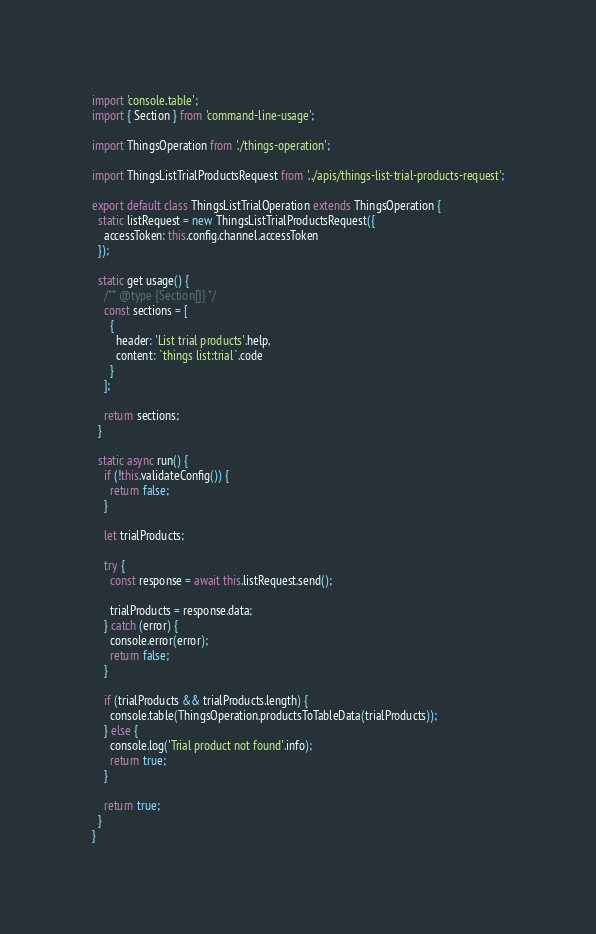Convert code to text. <code><loc_0><loc_0><loc_500><loc_500><_JavaScript_>import 'console.table';
import { Section } from 'command-line-usage';

import ThingsOperation from './things-operation';

import ThingsListTrialProductsRequest from '../apis/things-list-trial-products-request';

export default class ThingsListTrialOperation extends ThingsOperation {
  static listRequest = new ThingsListTrialProductsRequest({
    accessToken: this.config.channel.accessToken
  });

  static get usage() {
    /** @type {Section[]} */
    const sections = [
      {
        header: 'List trial products'.help,
        content: `things list:trial`.code
      }
    ];

    return sections;
  }

  static async run() {
    if (!this.validateConfig()) {
      return false;
    }

    let trialProducts;

    try {
      const response = await this.listRequest.send();

      trialProducts = response.data;
    } catch (error) {
      console.error(error);
      return false;
    }

    if (trialProducts && trialProducts.length) {
      console.table(ThingsOperation.productsToTableData(trialProducts));
    } else {
      console.log('Trial product not found'.info);
      return true;
    }

    return true;
  }
}
</code> 